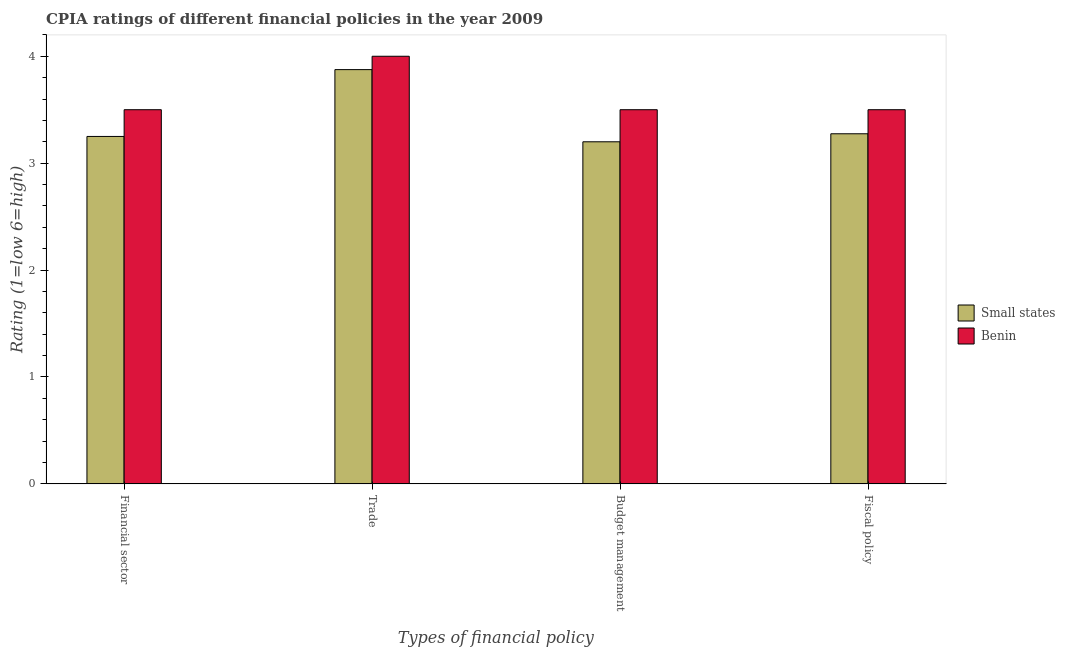How many different coloured bars are there?
Offer a very short reply. 2. How many groups of bars are there?
Provide a succinct answer. 4. How many bars are there on the 2nd tick from the right?
Give a very brief answer. 2. What is the label of the 4th group of bars from the left?
Your response must be concise. Fiscal policy. What is the cpia rating of fiscal policy in Small states?
Keep it short and to the point. 3.27. Across all countries, what is the maximum cpia rating of financial sector?
Ensure brevity in your answer.  3.5. Across all countries, what is the minimum cpia rating of trade?
Your answer should be very brief. 3.88. In which country was the cpia rating of trade maximum?
Offer a terse response. Benin. In which country was the cpia rating of trade minimum?
Your answer should be very brief. Small states. What is the total cpia rating of financial sector in the graph?
Keep it short and to the point. 6.75. What is the difference between the cpia rating of fiscal policy in Benin and that in Small states?
Keep it short and to the point. 0.23. What is the difference between the cpia rating of trade in Small states and the cpia rating of fiscal policy in Benin?
Offer a very short reply. 0.38. What is the average cpia rating of budget management per country?
Provide a short and direct response. 3.35. What is the difference between the cpia rating of financial sector and cpia rating of trade in Small states?
Ensure brevity in your answer.  -0.62. What is the ratio of the cpia rating of trade in Small states to that in Benin?
Your response must be concise. 0.97. Is the difference between the cpia rating of budget management in Small states and Benin greater than the difference between the cpia rating of fiscal policy in Small states and Benin?
Offer a terse response. No. What is the difference between the highest and the second highest cpia rating of trade?
Your answer should be compact. 0.12. What is the difference between the highest and the lowest cpia rating of fiscal policy?
Provide a succinct answer. 0.23. Is the sum of the cpia rating of trade in Small states and Benin greater than the maximum cpia rating of budget management across all countries?
Offer a very short reply. Yes. Is it the case that in every country, the sum of the cpia rating of trade and cpia rating of financial sector is greater than the sum of cpia rating of budget management and cpia rating of fiscal policy?
Offer a very short reply. Yes. What does the 1st bar from the left in Budget management represents?
Offer a terse response. Small states. What does the 1st bar from the right in Fiscal policy represents?
Offer a terse response. Benin. How many bars are there?
Offer a terse response. 8. How many countries are there in the graph?
Provide a succinct answer. 2. Does the graph contain any zero values?
Give a very brief answer. No. What is the title of the graph?
Your response must be concise. CPIA ratings of different financial policies in the year 2009. What is the label or title of the X-axis?
Your answer should be compact. Types of financial policy. What is the Rating (1=low 6=high) in Small states in Financial sector?
Make the answer very short. 3.25. What is the Rating (1=low 6=high) of Small states in Trade?
Offer a very short reply. 3.88. What is the Rating (1=low 6=high) of Benin in Budget management?
Make the answer very short. 3.5. What is the Rating (1=low 6=high) in Small states in Fiscal policy?
Offer a very short reply. 3.27. What is the Rating (1=low 6=high) in Benin in Fiscal policy?
Offer a very short reply. 3.5. Across all Types of financial policy, what is the maximum Rating (1=low 6=high) in Small states?
Your answer should be compact. 3.88. Across all Types of financial policy, what is the maximum Rating (1=low 6=high) in Benin?
Your answer should be very brief. 4. What is the total Rating (1=low 6=high) of Small states in the graph?
Ensure brevity in your answer.  13.6. What is the total Rating (1=low 6=high) of Benin in the graph?
Ensure brevity in your answer.  14.5. What is the difference between the Rating (1=low 6=high) in Small states in Financial sector and that in Trade?
Provide a short and direct response. -0.62. What is the difference between the Rating (1=low 6=high) of Benin in Financial sector and that in Budget management?
Offer a very short reply. 0. What is the difference between the Rating (1=low 6=high) in Small states in Financial sector and that in Fiscal policy?
Your answer should be very brief. -0.03. What is the difference between the Rating (1=low 6=high) of Benin in Financial sector and that in Fiscal policy?
Ensure brevity in your answer.  0. What is the difference between the Rating (1=low 6=high) in Small states in Trade and that in Budget management?
Provide a succinct answer. 0.68. What is the difference between the Rating (1=low 6=high) in Benin in Trade and that in Budget management?
Your response must be concise. 0.5. What is the difference between the Rating (1=low 6=high) in Benin in Trade and that in Fiscal policy?
Give a very brief answer. 0.5. What is the difference between the Rating (1=low 6=high) in Small states in Budget management and that in Fiscal policy?
Your answer should be very brief. -0.07. What is the difference between the Rating (1=low 6=high) of Small states in Financial sector and the Rating (1=low 6=high) of Benin in Trade?
Offer a very short reply. -0.75. What is the difference between the Rating (1=low 6=high) of Small states in Trade and the Rating (1=low 6=high) of Benin in Fiscal policy?
Ensure brevity in your answer.  0.38. What is the difference between the Rating (1=low 6=high) in Small states in Budget management and the Rating (1=low 6=high) in Benin in Fiscal policy?
Offer a terse response. -0.3. What is the average Rating (1=low 6=high) of Small states per Types of financial policy?
Offer a terse response. 3.4. What is the average Rating (1=low 6=high) in Benin per Types of financial policy?
Provide a short and direct response. 3.62. What is the difference between the Rating (1=low 6=high) in Small states and Rating (1=low 6=high) in Benin in Trade?
Give a very brief answer. -0.12. What is the difference between the Rating (1=low 6=high) of Small states and Rating (1=low 6=high) of Benin in Fiscal policy?
Keep it short and to the point. -0.23. What is the ratio of the Rating (1=low 6=high) in Small states in Financial sector to that in Trade?
Provide a short and direct response. 0.84. What is the ratio of the Rating (1=low 6=high) of Benin in Financial sector to that in Trade?
Your response must be concise. 0.88. What is the ratio of the Rating (1=low 6=high) of Small states in Financial sector to that in Budget management?
Provide a succinct answer. 1.02. What is the ratio of the Rating (1=low 6=high) in Small states in Financial sector to that in Fiscal policy?
Provide a short and direct response. 0.99. What is the ratio of the Rating (1=low 6=high) of Benin in Financial sector to that in Fiscal policy?
Offer a very short reply. 1. What is the ratio of the Rating (1=low 6=high) in Small states in Trade to that in Budget management?
Provide a short and direct response. 1.21. What is the ratio of the Rating (1=low 6=high) of Small states in Trade to that in Fiscal policy?
Provide a short and direct response. 1.18. What is the ratio of the Rating (1=low 6=high) of Small states in Budget management to that in Fiscal policy?
Provide a succinct answer. 0.98. What is the difference between the highest and the second highest Rating (1=low 6=high) of Benin?
Your answer should be very brief. 0.5. What is the difference between the highest and the lowest Rating (1=low 6=high) of Small states?
Offer a very short reply. 0.68. 